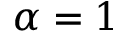Convert formula to latex. <formula><loc_0><loc_0><loc_500><loc_500>\alpha = 1</formula> 